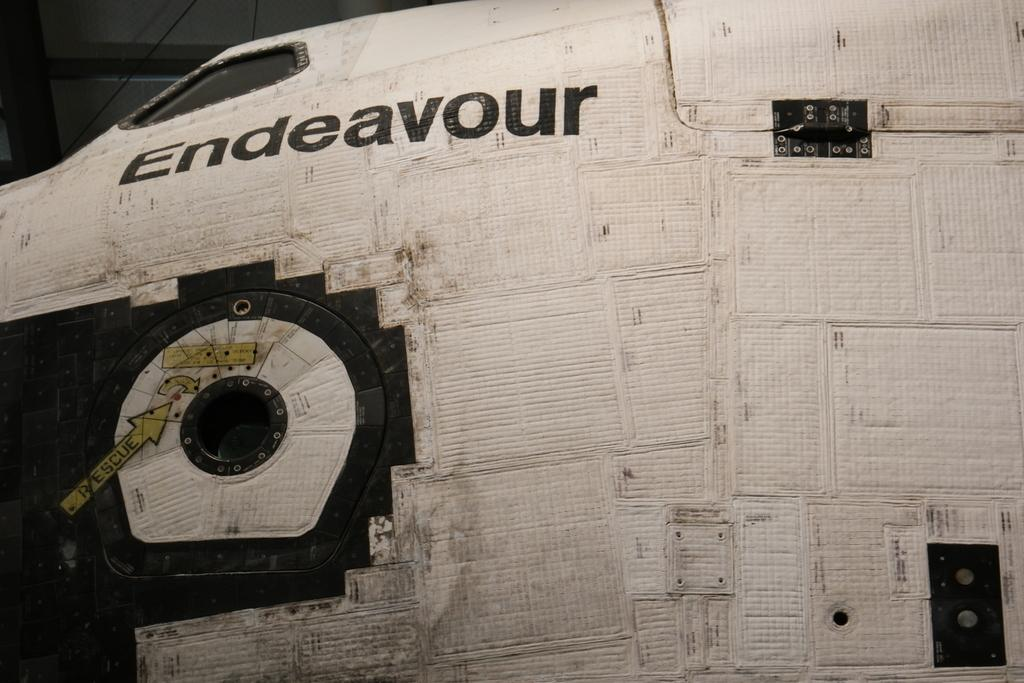<image>
Relay a brief, clear account of the picture shown. The body of the Endeavour is dirty and a bit beat up. 